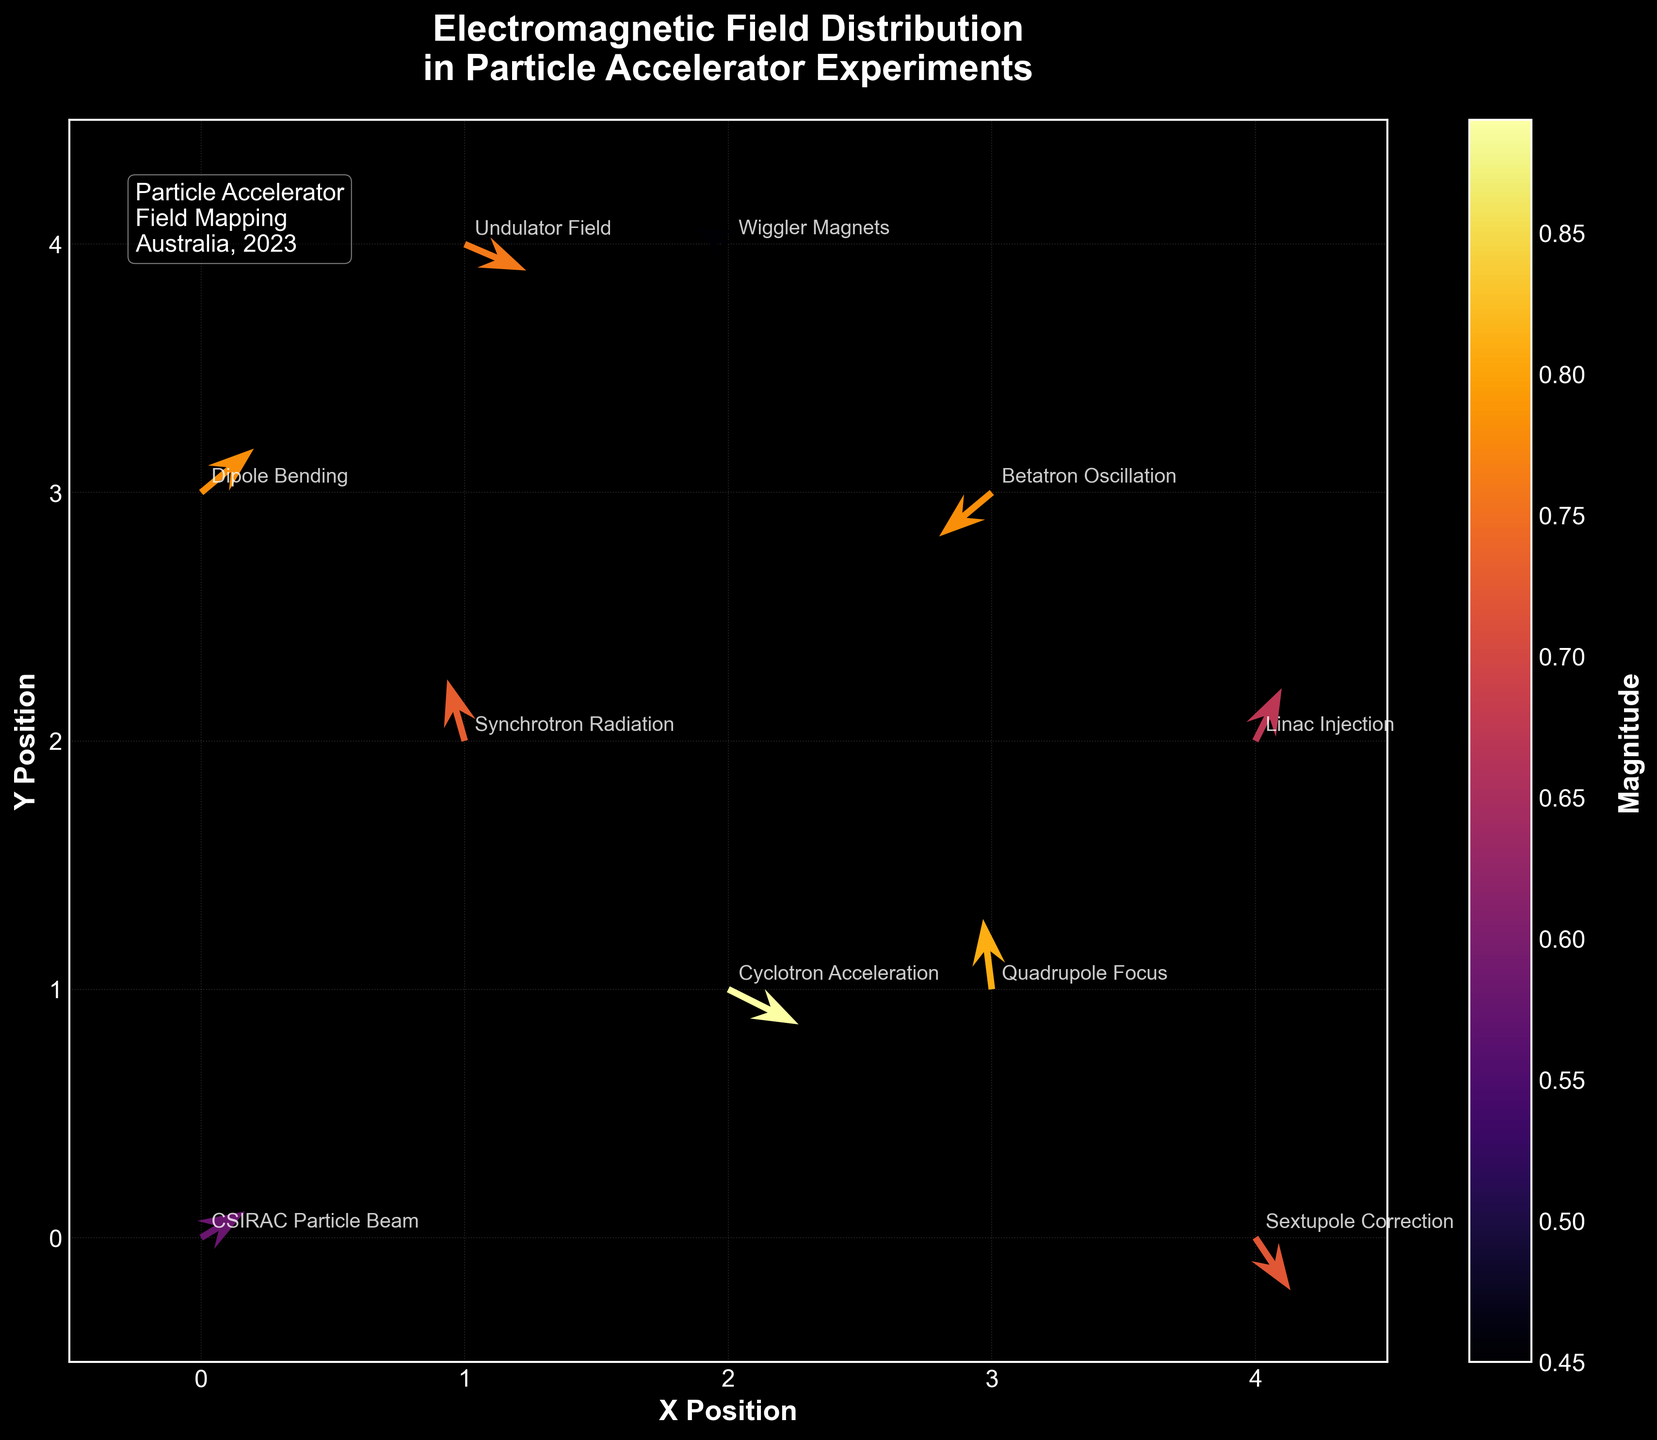What is the title of the figure? The title is located at the top center of the figure and reads: "Electromagnetic Field Distribution in Particle Accelerator Experiments."
Answer: Electromagnetic Field Distribution in Particle Accelerator Experiments What does the color of the arrows represent? The color of the arrows is associated with their magnitude, as indicated by the colorbar on the right side of the plot, which ranges from yellow (low magnitude) to red (high magnitude).
Answer: Magnitude How many unique experiments are labeled in the figure? There are a total of 10 unique labels corresponding to different experiments, each placed at the respective (x,y) coordinates.
Answer: 10 Which experiment has the largest magnitude and what is its value? By checking the color intensity and confirming with the data, the "Cyclotron Acceleration" experiment (2,1) has the largest magnitude of 0.89, as indicated by its dark red color.
Answer: Cyclotron Acceleration, 0.89 What are the x and y coordinates of the "Undulator Field" experiment? Locate the "Undulator Field" label in the plot and note its position; it is placed at coordinates (1,4).
Answer: (1,4) Which experiment has a positive u and negative v component, and what are its coordinates? Observe the direction of the arrows, identify which have a positive x component (u) and a negative y component (v); the "Cyclotron Acceleration" at (2,1) fits this description.
Answer: Cyclotron Acceleration, (2,1) Compare the magnitudes of the fields at (1,2) and (4,0). Which is larger and by how much? The magnitudes from the data are 0.73 for (1,2) and 0.72 for (4,0). Subtract 0.72 from 0.73 to find the difference: 0.01.
Answer: (1,2) is larger by 0.01 What is the average magnitude of the fields from the experiments "CSIRAC Particle Beam" and "Linac Injection"? The magnitudes are 0.58 for "CSIRAC Particle Beam" and 0.67 for "Linac Injection." Calculate the average: (0.58 + 0.67) / 2 = 0.625.
Answer: 0.625 Which experiments have arrows pointing predominantly downward (negative v component), and how many are there? Identify arrows pointing downward by their negative v components: "Cyclotron Acceleration," "Betatron Oscillation," "Undulator Field," "Quadrupole Focus," and "Sextupole Correction." Count them to get the total: 5.
Answer: 5 